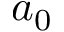Convert formula to latex. <formula><loc_0><loc_0><loc_500><loc_500>a _ { 0 }</formula> 